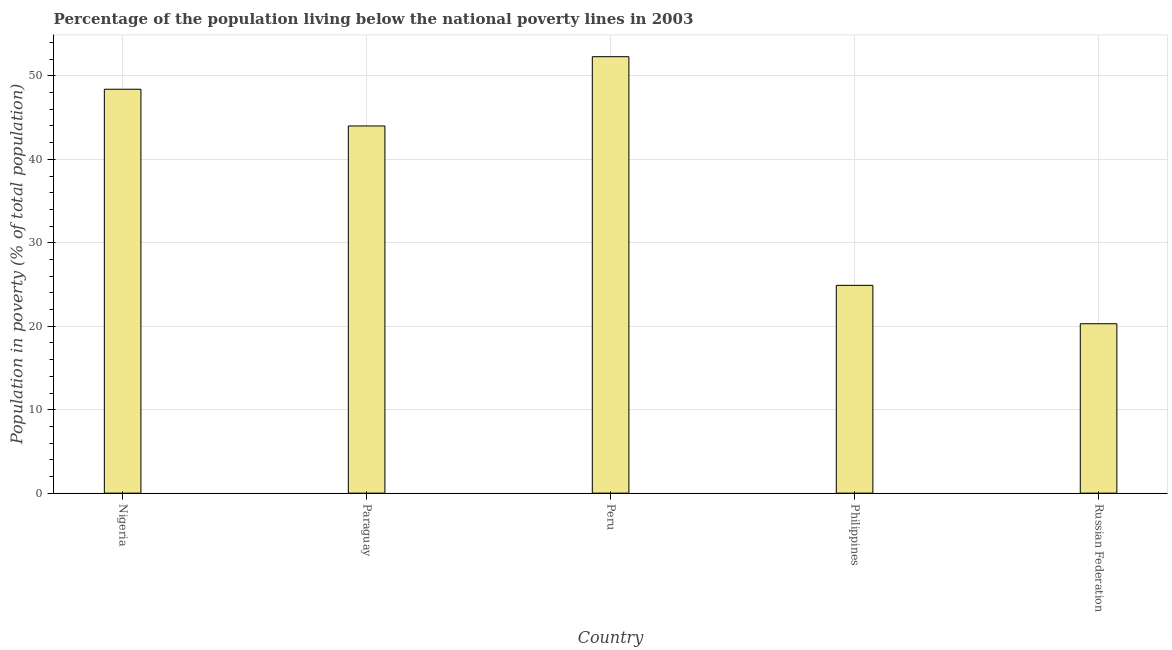Does the graph contain grids?
Give a very brief answer. Yes. What is the title of the graph?
Offer a terse response. Percentage of the population living below the national poverty lines in 2003. What is the label or title of the Y-axis?
Give a very brief answer. Population in poverty (% of total population). What is the percentage of population living below poverty line in Peru?
Your answer should be compact. 52.3. Across all countries, what is the maximum percentage of population living below poverty line?
Make the answer very short. 52.3. Across all countries, what is the minimum percentage of population living below poverty line?
Offer a very short reply. 20.3. In which country was the percentage of population living below poverty line maximum?
Provide a short and direct response. Peru. In which country was the percentage of population living below poverty line minimum?
Ensure brevity in your answer.  Russian Federation. What is the sum of the percentage of population living below poverty line?
Your answer should be very brief. 189.9. What is the difference between the percentage of population living below poverty line in Philippines and Russian Federation?
Keep it short and to the point. 4.6. What is the average percentage of population living below poverty line per country?
Provide a short and direct response. 37.98. What is the median percentage of population living below poverty line?
Your answer should be very brief. 44. What is the ratio of the percentage of population living below poverty line in Paraguay to that in Philippines?
Make the answer very short. 1.77. Is the percentage of population living below poverty line in Paraguay less than that in Philippines?
Your response must be concise. No. Is the difference between the percentage of population living below poverty line in Nigeria and Peru greater than the difference between any two countries?
Your answer should be compact. No. Is the sum of the percentage of population living below poverty line in Peru and Russian Federation greater than the maximum percentage of population living below poverty line across all countries?
Make the answer very short. Yes. What is the difference between the highest and the lowest percentage of population living below poverty line?
Your response must be concise. 32. In how many countries, is the percentage of population living below poverty line greater than the average percentage of population living below poverty line taken over all countries?
Give a very brief answer. 3. How many countries are there in the graph?
Your response must be concise. 5. What is the difference between two consecutive major ticks on the Y-axis?
Offer a terse response. 10. What is the Population in poverty (% of total population) in Nigeria?
Offer a very short reply. 48.4. What is the Population in poverty (% of total population) in Paraguay?
Provide a succinct answer. 44. What is the Population in poverty (% of total population) in Peru?
Provide a short and direct response. 52.3. What is the Population in poverty (% of total population) of Philippines?
Your answer should be very brief. 24.9. What is the Population in poverty (% of total population) in Russian Federation?
Provide a succinct answer. 20.3. What is the difference between the Population in poverty (% of total population) in Nigeria and Paraguay?
Your answer should be very brief. 4.4. What is the difference between the Population in poverty (% of total population) in Nigeria and Peru?
Offer a very short reply. -3.9. What is the difference between the Population in poverty (% of total population) in Nigeria and Philippines?
Offer a very short reply. 23.5. What is the difference between the Population in poverty (% of total population) in Nigeria and Russian Federation?
Offer a terse response. 28.1. What is the difference between the Population in poverty (% of total population) in Paraguay and Russian Federation?
Your answer should be very brief. 23.7. What is the difference between the Population in poverty (% of total population) in Peru and Philippines?
Keep it short and to the point. 27.4. What is the difference between the Population in poverty (% of total population) in Peru and Russian Federation?
Offer a terse response. 32. What is the difference between the Population in poverty (% of total population) in Philippines and Russian Federation?
Provide a succinct answer. 4.6. What is the ratio of the Population in poverty (% of total population) in Nigeria to that in Paraguay?
Provide a short and direct response. 1.1. What is the ratio of the Population in poverty (% of total population) in Nigeria to that in Peru?
Offer a terse response. 0.93. What is the ratio of the Population in poverty (% of total population) in Nigeria to that in Philippines?
Your answer should be very brief. 1.94. What is the ratio of the Population in poverty (% of total population) in Nigeria to that in Russian Federation?
Ensure brevity in your answer.  2.38. What is the ratio of the Population in poverty (% of total population) in Paraguay to that in Peru?
Offer a very short reply. 0.84. What is the ratio of the Population in poverty (% of total population) in Paraguay to that in Philippines?
Your answer should be very brief. 1.77. What is the ratio of the Population in poverty (% of total population) in Paraguay to that in Russian Federation?
Provide a succinct answer. 2.17. What is the ratio of the Population in poverty (% of total population) in Peru to that in Philippines?
Provide a succinct answer. 2.1. What is the ratio of the Population in poverty (% of total population) in Peru to that in Russian Federation?
Your response must be concise. 2.58. What is the ratio of the Population in poverty (% of total population) in Philippines to that in Russian Federation?
Offer a very short reply. 1.23. 